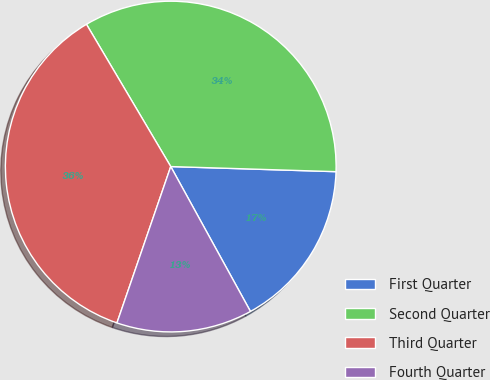Convert chart. <chart><loc_0><loc_0><loc_500><loc_500><pie_chart><fcel>First Quarter<fcel>Second Quarter<fcel>Third Quarter<fcel>Fourth Quarter<nl><fcel>16.5%<fcel>34.0%<fcel>36.21%<fcel>13.28%<nl></chart> 